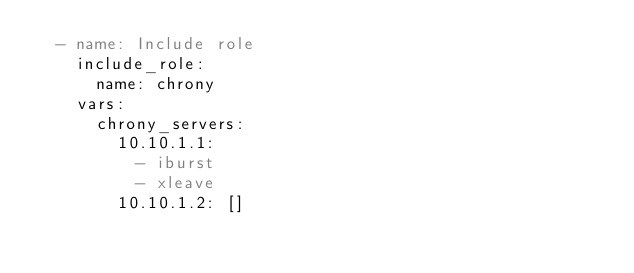Convert code to text. <code><loc_0><loc_0><loc_500><loc_500><_YAML_>  - name: Include role
    include_role:
      name: chrony
    vars:
      chrony_servers:
        10.10.1.1:
          - iburst
          - xleave
        10.10.1.2: []
</code> 